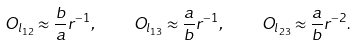Convert formula to latex. <formula><loc_0><loc_0><loc_500><loc_500>O _ { l _ { 1 2 } } \approx \frac { b } { a } r ^ { - 1 } , \quad O _ { l _ { 1 3 } } \approx \frac { a } { b } r ^ { - 1 } , \quad O _ { l _ { 2 3 } } \approx \frac { a } { b } r ^ { - 2 } .</formula> 